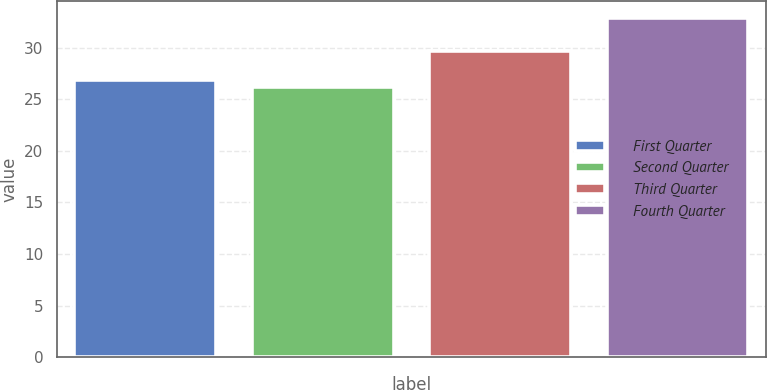Convert chart to OTSL. <chart><loc_0><loc_0><loc_500><loc_500><bar_chart><fcel>First Quarter<fcel>Second Quarter<fcel>Third Quarter<fcel>Fourth Quarter<nl><fcel>26.85<fcel>26.18<fcel>29.71<fcel>32.85<nl></chart> 